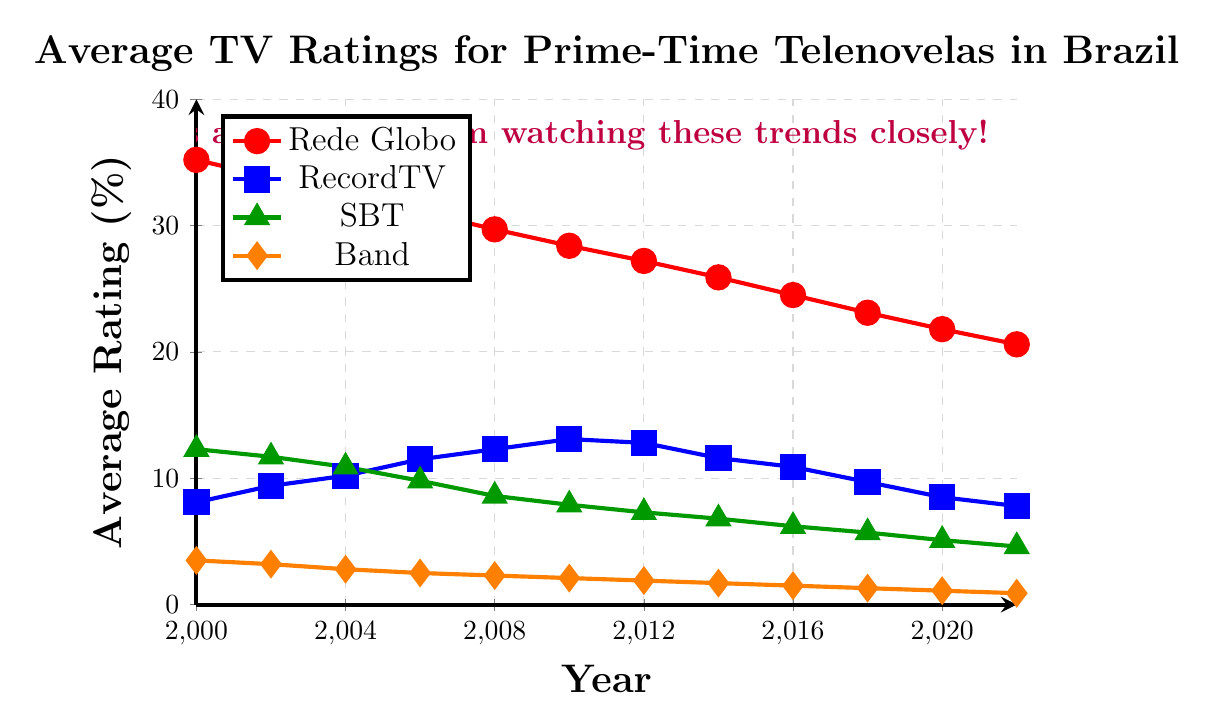What's the overall trend in TV ratings for Rede Globo from 2000 to 2022? The trend in Rede Globo's TV ratings shows a consistent decline from 35.2 in 2000 to 20.6 in 2022. This is observed by noting the continual decrease each year in the plotted line.
Answer: Decline Which network had the highest average rating in 2010? In 2010, Rede Globo had the highest average rating at 28.4, followed by RecordTV with 13.1, SBT with 7.9, and Band with 2.1.
Answer: Rede Globo How do the TV ratings for RecordTV and SBT compare in 2008? In 2008, the TV ratings for RecordTV were 12.3, while for SBT, it was 8.6. Since 12.3 is greater than 8.6, RecordTV had higher ratings.
Answer: RecordTV had higher ratings What is the difference in TV ratings between Rede Globo and Band in 2022? In 2022, Rede Globo had ratings of 20.6 and Band had ratings of 0.9. The difference is 20.6 - 0.9.
Answer: 19.7 What was the trend in TV ratings for Band from 2000 to 2022? From 2000 to 2022, Band's TV ratings consistently declined from 3.5 down to 0.9. This pattern is visible in the decreasing points of the orange line.
Answer: Decline In which year did RecordTV have its peak TV ratings, and what was the value? RecordTV had its peak TV ratings in 2010 with a value of 13.1. This is identified as the highest plotted point on the blue line.
Answer: 2010, 13.1 Compare the TV ratings of Rede Globo and RecordTV in 2000 and explain the difference. In 2000, Rede Globo's ratings were 35.2 and RecordTV's ratings were 8.1. The difference is 35.2 - 8.1, which shows Rede Globo had a significantly higher rating by 27.1 points.
Answer: 27.1 What is the average TV rating of SBT across all the years shown? The ratings for SBT from 2000 to 2022 are summed (12.3 + 11.7 + 10.9 + 9.8 + 8.6 + 7.9 + 7.3 + 6.8 + 6.2 + 5.7 + 5.1 + 4.6) to get 96.9 and then divided by the number of years (12).
Answer: 8.075 Which network showed the most consistent decline in TV ratings over the given period? Rede Globo showed the most consistent decline, as visible from the steady downward slope of the red line from 35.2 in 2000 to 20.6 in 2022.
Answer: Rede Globo 